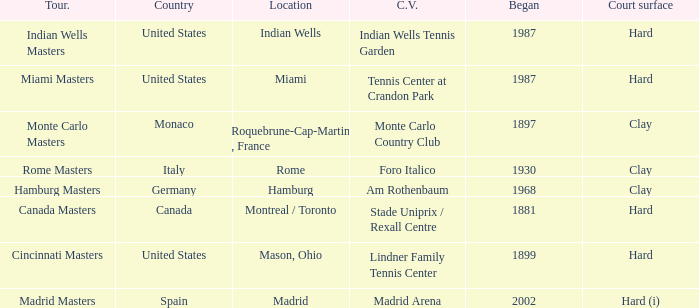Rome is in which country? Italy. 